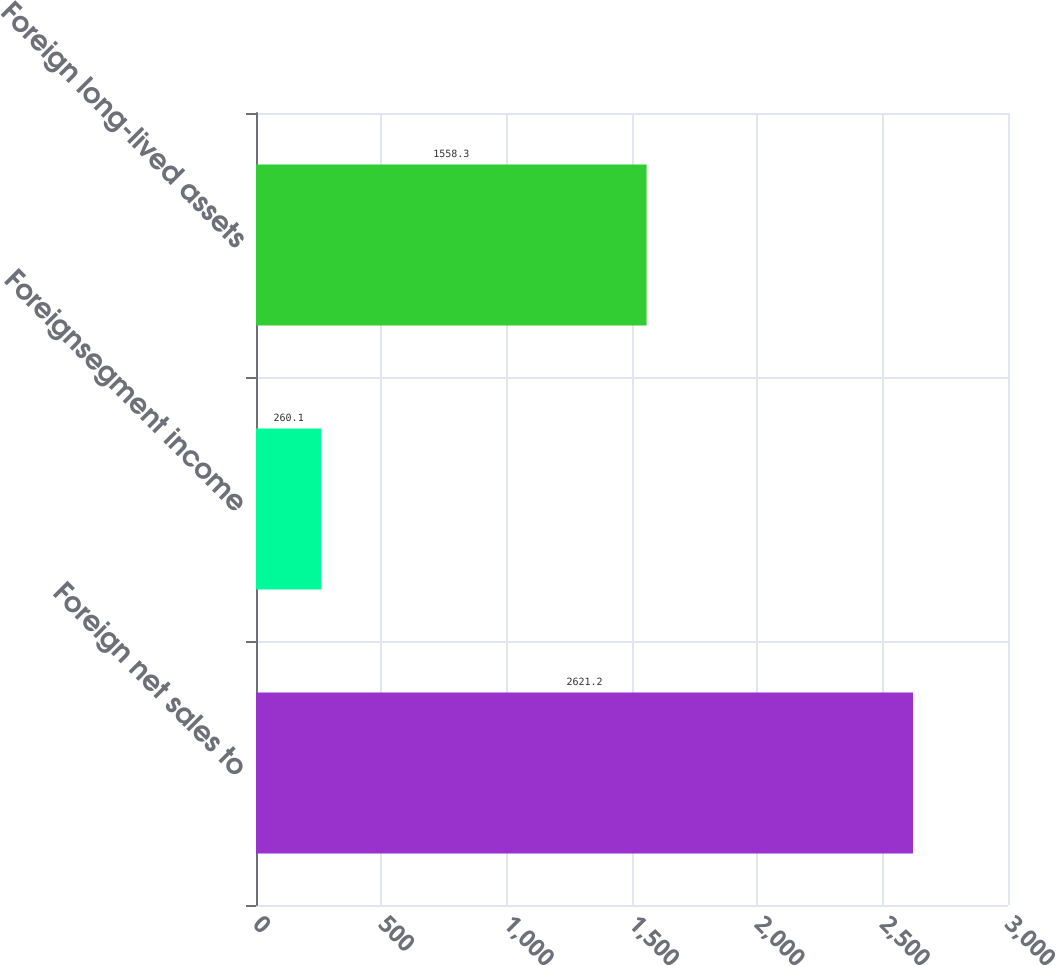<chart> <loc_0><loc_0><loc_500><loc_500><bar_chart><fcel>Foreign net sales to<fcel>Foreignsegment income<fcel>Foreign long-lived assets<nl><fcel>2621.2<fcel>260.1<fcel>1558.3<nl></chart> 